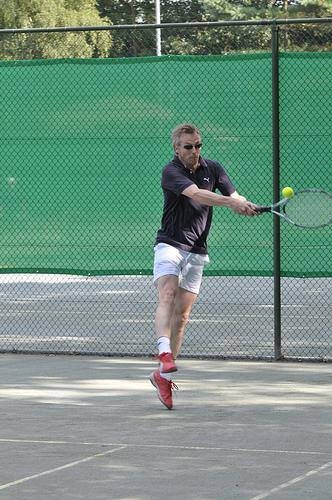Is the man wearing sneakers?
Be succinct. Yes. What sport is the man playing?
Give a very brief answer. Tennis. Is the man in motion?
Quick response, please. Yes. 